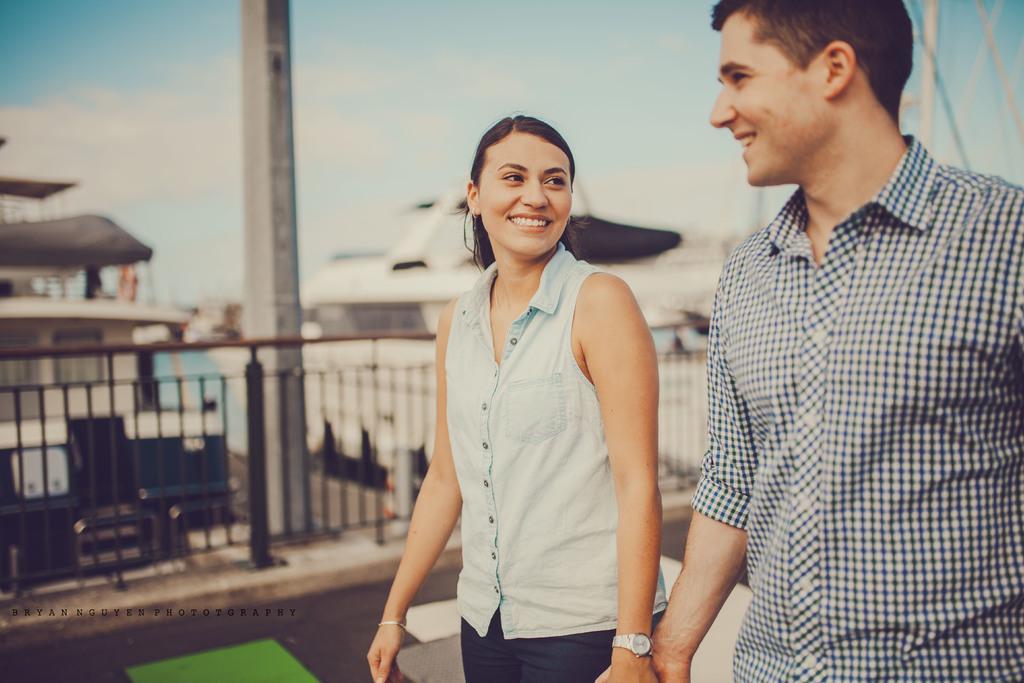In one or two sentences, can you explain what this image depicts? There are two people holding hands each other and smiling. In the background it is blurry and we can see pole, ships, fence and sky with clouds. 